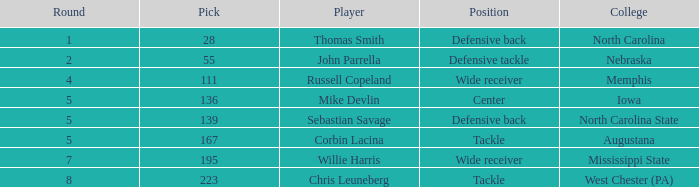What is the sum of Round with a Pick that is 55? 2.0. 